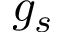<formula> <loc_0><loc_0><loc_500><loc_500>g _ { s }</formula> 